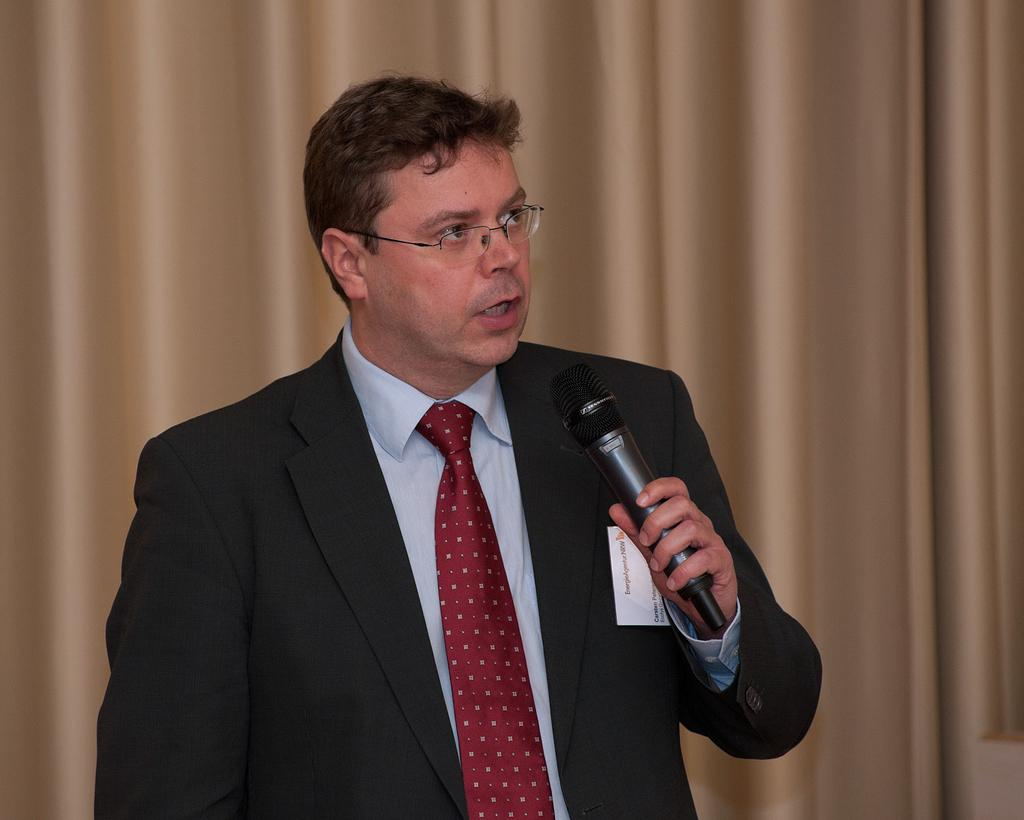Who is present in the image? There is a man in the image. What is the man doing in the image? The man is talking in the image. What object is the man holding in the image? The man is holding a microphone in the image. What can be seen in the background of the image? There is a curtain in the background of the image. Can you see an airplane flying in the background of the image? No, there is no airplane visible in the image. 